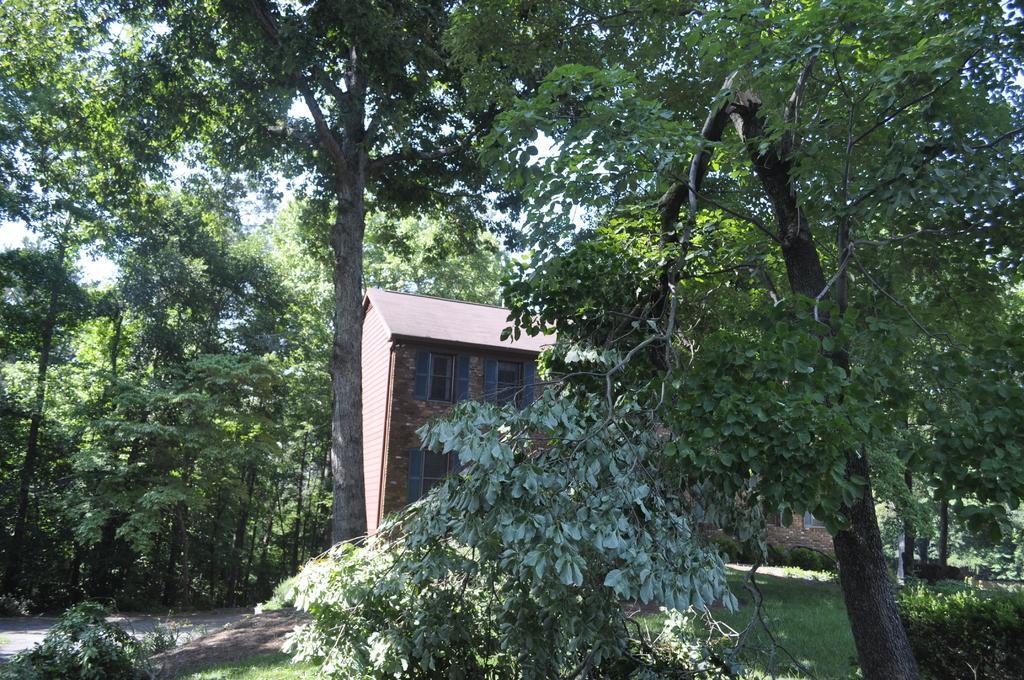Could you give a brief overview of what you see in this image? In the image there are many trees and in between the trees there is a house. 